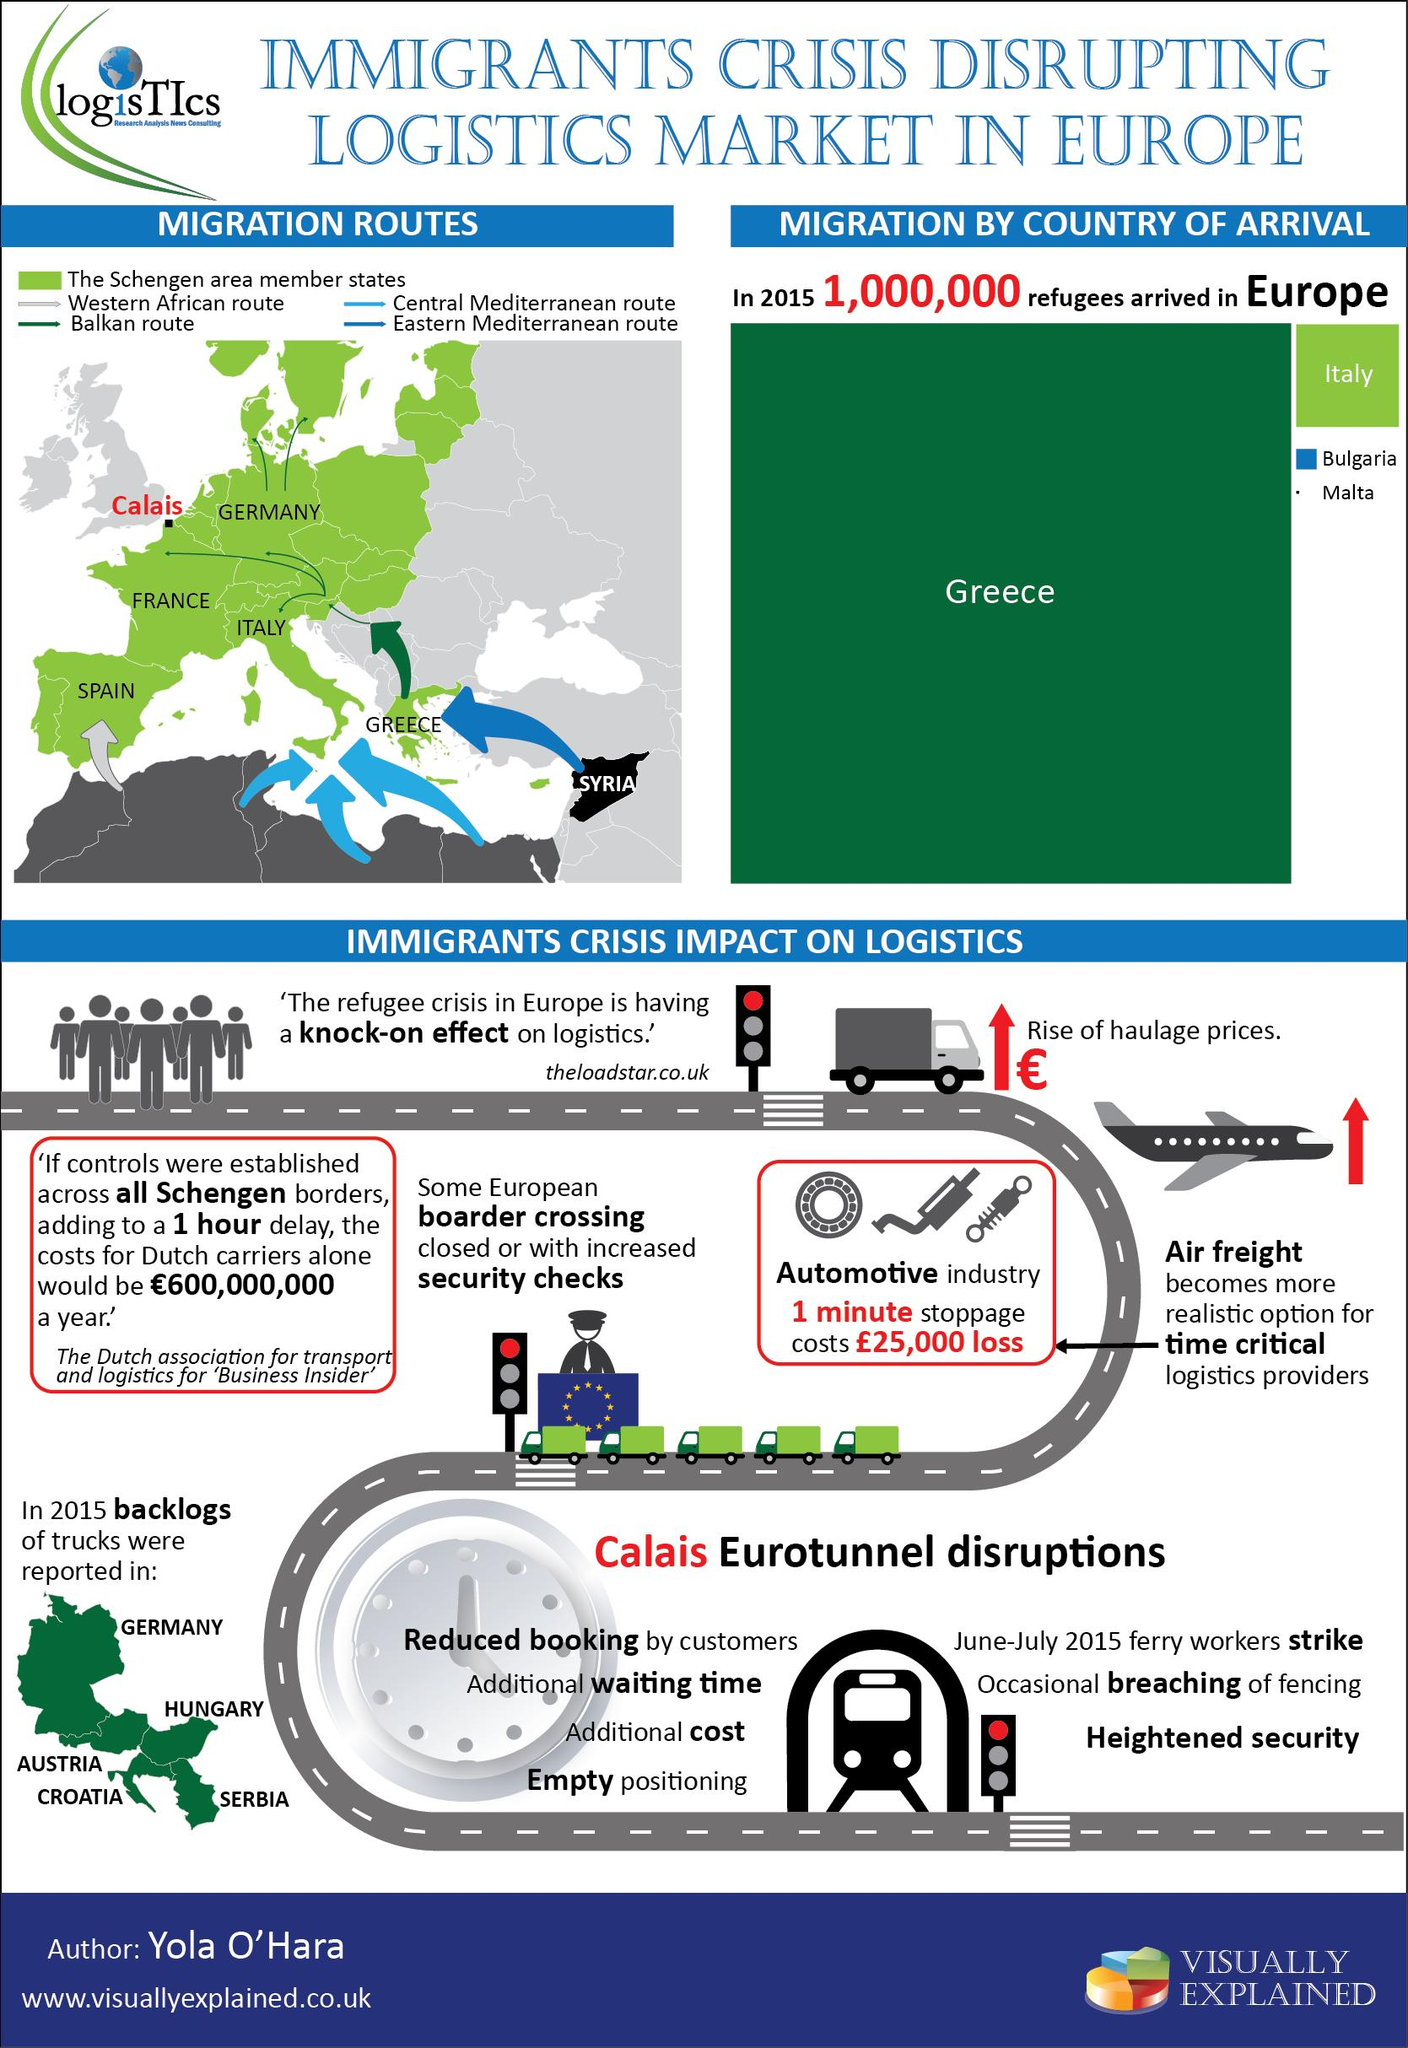Outline some significant characteristics in this image. The second highest number of immigrants have arrived in Italy, which is located on the European continent. The country portrayed in a black background on the map is Syria. 